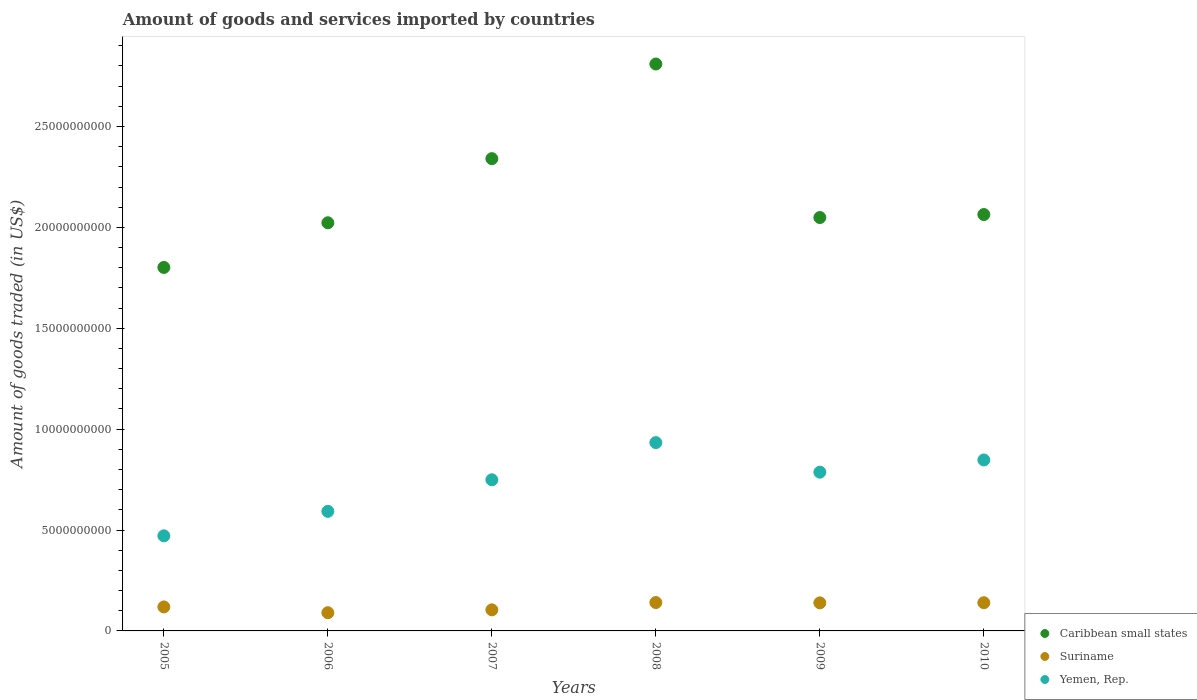How many different coloured dotlines are there?
Your answer should be compact. 3. What is the total amount of goods and services imported in Yemen, Rep. in 2005?
Your answer should be very brief. 4.71e+09. Across all years, what is the maximum total amount of goods and services imported in Yemen, Rep.?
Ensure brevity in your answer.  9.33e+09. Across all years, what is the minimum total amount of goods and services imported in Suriname?
Make the answer very short. 9.03e+08. In which year was the total amount of goods and services imported in Yemen, Rep. maximum?
Keep it short and to the point. 2008. What is the total total amount of goods and services imported in Caribbean small states in the graph?
Your answer should be compact. 1.31e+11. What is the difference between the total amount of goods and services imported in Yemen, Rep. in 2005 and that in 2007?
Provide a short and direct response. -2.78e+09. What is the difference between the total amount of goods and services imported in Yemen, Rep. in 2008 and the total amount of goods and services imported in Caribbean small states in 2007?
Provide a succinct answer. -1.41e+1. What is the average total amount of goods and services imported in Caribbean small states per year?
Provide a succinct answer. 2.18e+1. In the year 2008, what is the difference between the total amount of goods and services imported in Suriname and total amount of goods and services imported in Yemen, Rep.?
Ensure brevity in your answer.  -7.93e+09. What is the ratio of the total amount of goods and services imported in Suriname in 2007 to that in 2008?
Your response must be concise. 0.74. Is the total amount of goods and services imported in Yemen, Rep. in 2009 less than that in 2010?
Provide a succinct answer. Yes. What is the difference between the highest and the second highest total amount of goods and services imported in Suriname?
Give a very brief answer. 8.80e+06. What is the difference between the highest and the lowest total amount of goods and services imported in Yemen, Rep.?
Your answer should be very brief. 4.62e+09. Is it the case that in every year, the sum of the total amount of goods and services imported in Caribbean small states and total amount of goods and services imported in Suriname  is greater than the total amount of goods and services imported in Yemen, Rep.?
Your answer should be very brief. Yes. How many dotlines are there?
Your answer should be very brief. 3. Does the graph contain any zero values?
Provide a short and direct response. No. Does the graph contain grids?
Provide a short and direct response. No. Where does the legend appear in the graph?
Keep it short and to the point. Bottom right. How many legend labels are there?
Provide a short and direct response. 3. How are the legend labels stacked?
Keep it short and to the point. Vertical. What is the title of the graph?
Your answer should be compact. Amount of goods and services imported by countries. Does "Liechtenstein" appear as one of the legend labels in the graph?
Your response must be concise. No. What is the label or title of the X-axis?
Ensure brevity in your answer.  Years. What is the label or title of the Y-axis?
Make the answer very short. Amount of goods traded (in US$). What is the Amount of goods traded (in US$) in Caribbean small states in 2005?
Provide a short and direct response. 1.80e+1. What is the Amount of goods traded (in US$) in Suriname in 2005?
Your response must be concise. 1.19e+09. What is the Amount of goods traded (in US$) of Yemen, Rep. in 2005?
Your answer should be compact. 4.71e+09. What is the Amount of goods traded (in US$) of Caribbean small states in 2006?
Provide a short and direct response. 2.02e+1. What is the Amount of goods traded (in US$) of Suriname in 2006?
Give a very brief answer. 9.03e+08. What is the Amount of goods traded (in US$) of Yemen, Rep. in 2006?
Offer a terse response. 5.93e+09. What is the Amount of goods traded (in US$) of Caribbean small states in 2007?
Give a very brief answer. 2.34e+1. What is the Amount of goods traded (in US$) of Suriname in 2007?
Your answer should be very brief. 1.04e+09. What is the Amount of goods traded (in US$) of Yemen, Rep. in 2007?
Your response must be concise. 7.49e+09. What is the Amount of goods traded (in US$) in Caribbean small states in 2008?
Give a very brief answer. 2.81e+1. What is the Amount of goods traded (in US$) of Suriname in 2008?
Provide a short and direct response. 1.41e+09. What is the Amount of goods traded (in US$) of Yemen, Rep. in 2008?
Offer a very short reply. 9.33e+09. What is the Amount of goods traded (in US$) in Caribbean small states in 2009?
Your answer should be compact. 2.05e+1. What is the Amount of goods traded (in US$) in Suriname in 2009?
Your answer should be very brief. 1.39e+09. What is the Amount of goods traded (in US$) of Yemen, Rep. in 2009?
Offer a terse response. 7.87e+09. What is the Amount of goods traded (in US$) of Caribbean small states in 2010?
Your answer should be compact. 2.06e+1. What is the Amount of goods traded (in US$) of Suriname in 2010?
Provide a succinct answer. 1.40e+09. What is the Amount of goods traded (in US$) of Yemen, Rep. in 2010?
Offer a terse response. 8.47e+09. Across all years, what is the maximum Amount of goods traded (in US$) of Caribbean small states?
Your response must be concise. 2.81e+1. Across all years, what is the maximum Amount of goods traded (in US$) in Suriname?
Provide a short and direct response. 1.41e+09. Across all years, what is the maximum Amount of goods traded (in US$) of Yemen, Rep.?
Keep it short and to the point. 9.33e+09. Across all years, what is the minimum Amount of goods traded (in US$) in Caribbean small states?
Offer a terse response. 1.80e+1. Across all years, what is the minimum Amount of goods traded (in US$) of Suriname?
Provide a short and direct response. 9.03e+08. Across all years, what is the minimum Amount of goods traded (in US$) in Yemen, Rep.?
Make the answer very short. 4.71e+09. What is the total Amount of goods traded (in US$) of Caribbean small states in the graph?
Your answer should be compact. 1.31e+11. What is the total Amount of goods traded (in US$) of Suriname in the graph?
Offer a very short reply. 7.33e+09. What is the total Amount of goods traded (in US$) in Yemen, Rep. in the graph?
Offer a very short reply. 4.38e+1. What is the difference between the Amount of goods traded (in US$) of Caribbean small states in 2005 and that in 2006?
Ensure brevity in your answer.  -2.21e+09. What is the difference between the Amount of goods traded (in US$) of Suriname in 2005 and that in 2006?
Offer a very short reply. 2.86e+08. What is the difference between the Amount of goods traded (in US$) in Yemen, Rep. in 2005 and that in 2006?
Give a very brief answer. -1.21e+09. What is the difference between the Amount of goods traded (in US$) of Caribbean small states in 2005 and that in 2007?
Your answer should be compact. -5.39e+09. What is the difference between the Amount of goods traded (in US$) in Suriname in 2005 and that in 2007?
Provide a short and direct response. 1.44e+08. What is the difference between the Amount of goods traded (in US$) in Yemen, Rep. in 2005 and that in 2007?
Ensure brevity in your answer.  -2.78e+09. What is the difference between the Amount of goods traded (in US$) of Caribbean small states in 2005 and that in 2008?
Offer a terse response. -1.01e+1. What is the difference between the Amount of goods traded (in US$) of Suriname in 2005 and that in 2008?
Offer a very short reply. -2.18e+08. What is the difference between the Amount of goods traded (in US$) in Yemen, Rep. in 2005 and that in 2008?
Your answer should be very brief. -4.62e+09. What is the difference between the Amount of goods traded (in US$) of Caribbean small states in 2005 and that in 2009?
Provide a short and direct response. -2.47e+09. What is the difference between the Amount of goods traded (in US$) in Suriname in 2005 and that in 2009?
Keep it short and to the point. -2.02e+08. What is the difference between the Amount of goods traded (in US$) in Yemen, Rep. in 2005 and that in 2009?
Your response must be concise. -3.15e+09. What is the difference between the Amount of goods traded (in US$) in Caribbean small states in 2005 and that in 2010?
Offer a very short reply. -2.62e+09. What is the difference between the Amount of goods traded (in US$) in Suriname in 2005 and that in 2010?
Offer a very short reply. -2.09e+08. What is the difference between the Amount of goods traded (in US$) of Yemen, Rep. in 2005 and that in 2010?
Offer a terse response. -3.76e+09. What is the difference between the Amount of goods traded (in US$) of Caribbean small states in 2006 and that in 2007?
Your answer should be very brief. -3.18e+09. What is the difference between the Amount of goods traded (in US$) in Suriname in 2006 and that in 2007?
Your answer should be compact. -1.42e+08. What is the difference between the Amount of goods traded (in US$) in Yemen, Rep. in 2006 and that in 2007?
Provide a short and direct response. -1.56e+09. What is the difference between the Amount of goods traded (in US$) in Caribbean small states in 2006 and that in 2008?
Ensure brevity in your answer.  -7.87e+09. What is the difference between the Amount of goods traded (in US$) of Suriname in 2006 and that in 2008?
Give a very brief answer. -5.04e+08. What is the difference between the Amount of goods traded (in US$) of Yemen, Rep. in 2006 and that in 2008?
Your response must be concise. -3.41e+09. What is the difference between the Amount of goods traded (in US$) in Caribbean small states in 2006 and that in 2009?
Your answer should be very brief. -2.59e+08. What is the difference between the Amount of goods traded (in US$) of Suriname in 2006 and that in 2009?
Offer a terse response. -4.88e+08. What is the difference between the Amount of goods traded (in US$) of Yemen, Rep. in 2006 and that in 2009?
Provide a short and direct response. -1.94e+09. What is the difference between the Amount of goods traded (in US$) of Caribbean small states in 2006 and that in 2010?
Offer a terse response. -4.09e+08. What is the difference between the Amount of goods traded (in US$) in Suriname in 2006 and that in 2010?
Ensure brevity in your answer.  -4.95e+08. What is the difference between the Amount of goods traded (in US$) in Yemen, Rep. in 2006 and that in 2010?
Provide a succinct answer. -2.55e+09. What is the difference between the Amount of goods traded (in US$) of Caribbean small states in 2007 and that in 2008?
Your response must be concise. -4.69e+09. What is the difference between the Amount of goods traded (in US$) of Suriname in 2007 and that in 2008?
Offer a very short reply. -3.62e+08. What is the difference between the Amount of goods traded (in US$) in Yemen, Rep. in 2007 and that in 2008?
Your answer should be compact. -1.84e+09. What is the difference between the Amount of goods traded (in US$) of Caribbean small states in 2007 and that in 2009?
Provide a short and direct response. 2.92e+09. What is the difference between the Amount of goods traded (in US$) of Suriname in 2007 and that in 2009?
Make the answer very short. -3.46e+08. What is the difference between the Amount of goods traded (in US$) of Yemen, Rep. in 2007 and that in 2009?
Keep it short and to the point. -3.78e+08. What is the difference between the Amount of goods traded (in US$) in Caribbean small states in 2007 and that in 2010?
Make the answer very short. 2.77e+09. What is the difference between the Amount of goods traded (in US$) in Suriname in 2007 and that in 2010?
Offer a terse response. -3.53e+08. What is the difference between the Amount of goods traded (in US$) of Yemen, Rep. in 2007 and that in 2010?
Keep it short and to the point. -9.83e+08. What is the difference between the Amount of goods traded (in US$) of Caribbean small states in 2008 and that in 2009?
Your response must be concise. 7.61e+09. What is the difference between the Amount of goods traded (in US$) in Suriname in 2008 and that in 2009?
Give a very brief answer. 1.60e+07. What is the difference between the Amount of goods traded (in US$) in Yemen, Rep. in 2008 and that in 2009?
Your response must be concise. 1.47e+09. What is the difference between the Amount of goods traded (in US$) in Caribbean small states in 2008 and that in 2010?
Provide a short and direct response. 7.46e+09. What is the difference between the Amount of goods traded (in US$) in Suriname in 2008 and that in 2010?
Keep it short and to the point. 8.80e+06. What is the difference between the Amount of goods traded (in US$) in Yemen, Rep. in 2008 and that in 2010?
Your answer should be compact. 8.61e+08. What is the difference between the Amount of goods traded (in US$) in Caribbean small states in 2009 and that in 2010?
Provide a succinct answer. -1.49e+08. What is the difference between the Amount of goods traded (in US$) of Suriname in 2009 and that in 2010?
Ensure brevity in your answer.  -7.20e+06. What is the difference between the Amount of goods traded (in US$) in Yemen, Rep. in 2009 and that in 2010?
Your response must be concise. -6.05e+08. What is the difference between the Amount of goods traded (in US$) in Caribbean small states in 2005 and the Amount of goods traded (in US$) in Suriname in 2006?
Ensure brevity in your answer.  1.71e+1. What is the difference between the Amount of goods traded (in US$) of Caribbean small states in 2005 and the Amount of goods traded (in US$) of Yemen, Rep. in 2006?
Give a very brief answer. 1.21e+1. What is the difference between the Amount of goods traded (in US$) in Suriname in 2005 and the Amount of goods traded (in US$) in Yemen, Rep. in 2006?
Make the answer very short. -4.74e+09. What is the difference between the Amount of goods traded (in US$) of Caribbean small states in 2005 and the Amount of goods traded (in US$) of Suriname in 2007?
Keep it short and to the point. 1.70e+1. What is the difference between the Amount of goods traded (in US$) in Caribbean small states in 2005 and the Amount of goods traded (in US$) in Yemen, Rep. in 2007?
Provide a succinct answer. 1.05e+1. What is the difference between the Amount of goods traded (in US$) in Suriname in 2005 and the Amount of goods traded (in US$) in Yemen, Rep. in 2007?
Ensure brevity in your answer.  -6.30e+09. What is the difference between the Amount of goods traded (in US$) of Caribbean small states in 2005 and the Amount of goods traded (in US$) of Suriname in 2008?
Ensure brevity in your answer.  1.66e+1. What is the difference between the Amount of goods traded (in US$) in Caribbean small states in 2005 and the Amount of goods traded (in US$) in Yemen, Rep. in 2008?
Make the answer very short. 8.68e+09. What is the difference between the Amount of goods traded (in US$) in Suriname in 2005 and the Amount of goods traded (in US$) in Yemen, Rep. in 2008?
Provide a succinct answer. -8.14e+09. What is the difference between the Amount of goods traded (in US$) in Caribbean small states in 2005 and the Amount of goods traded (in US$) in Suriname in 2009?
Your answer should be compact. 1.66e+1. What is the difference between the Amount of goods traded (in US$) in Caribbean small states in 2005 and the Amount of goods traded (in US$) in Yemen, Rep. in 2009?
Offer a very short reply. 1.01e+1. What is the difference between the Amount of goods traded (in US$) in Suriname in 2005 and the Amount of goods traded (in US$) in Yemen, Rep. in 2009?
Offer a terse response. -6.68e+09. What is the difference between the Amount of goods traded (in US$) of Caribbean small states in 2005 and the Amount of goods traded (in US$) of Suriname in 2010?
Provide a succinct answer. 1.66e+1. What is the difference between the Amount of goods traded (in US$) in Caribbean small states in 2005 and the Amount of goods traded (in US$) in Yemen, Rep. in 2010?
Provide a short and direct response. 9.54e+09. What is the difference between the Amount of goods traded (in US$) of Suriname in 2005 and the Amount of goods traded (in US$) of Yemen, Rep. in 2010?
Provide a short and direct response. -7.28e+09. What is the difference between the Amount of goods traded (in US$) in Caribbean small states in 2006 and the Amount of goods traded (in US$) in Suriname in 2007?
Make the answer very short. 1.92e+1. What is the difference between the Amount of goods traded (in US$) in Caribbean small states in 2006 and the Amount of goods traded (in US$) in Yemen, Rep. in 2007?
Offer a very short reply. 1.27e+1. What is the difference between the Amount of goods traded (in US$) of Suriname in 2006 and the Amount of goods traded (in US$) of Yemen, Rep. in 2007?
Your answer should be very brief. -6.59e+09. What is the difference between the Amount of goods traded (in US$) of Caribbean small states in 2006 and the Amount of goods traded (in US$) of Suriname in 2008?
Offer a terse response. 1.88e+1. What is the difference between the Amount of goods traded (in US$) in Caribbean small states in 2006 and the Amount of goods traded (in US$) in Yemen, Rep. in 2008?
Make the answer very short. 1.09e+1. What is the difference between the Amount of goods traded (in US$) in Suriname in 2006 and the Amount of goods traded (in US$) in Yemen, Rep. in 2008?
Ensure brevity in your answer.  -8.43e+09. What is the difference between the Amount of goods traded (in US$) of Caribbean small states in 2006 and the Amount of goods traded (in US$) of Suriname in 2009?
Ensure brevity in your answer.  1.88e+1. What is the difference between the Amount of goods traded (in US$) in Caribbean small states in 2006 and the Amount of goods traded (in US$) in Yemen, Rep. in 2009?
Ensure brevity in your answer.  1.24e+1. What is the difference between the Amount of goods traded (in US$) of Suriname in 2006 and the Amount of goods traded (in US$) of Yemen, Rep. in 2009?
Your answer should be compact. -6.97e+09. What is the difference between the Amount of goods traded (in US$) of Caribbean small states in 2006 and the Amount of goods traded (in US$) of Suriname in 2010?
Offer a very short reply. 1.88e+1. What is the difference between the Amount of goods traded (in US$) in Caribbean small states in 2006 and the Amount of goods traded (in US$) in Yemen, Rep. in 2010?
Offer a terse response. 1.18e+1. What is the difference between the Amount of goods traded (in US$) in Suriname in 2006 and the Amount of goods traded (in US$) in Yemen, Rep. in 2010?
Keep it short and to the point. -7.57e+09. What is the difference between the Amount of goods traded (in US$) in Caribbean small states in 2007 and the Amount of goods traded (in US$) in Suriname in 2008?
Provide a succinct answer. 2.20e+1. What is the difference between the Amount of goods traded (in US$) of Caribbean small states in 2007 and the Amount of goods traded (in US$) of Yemen, Rep. in 2008?
Your answer should be compact. 1.41e+1. What is the difference between the Amount of goods traded (in US$) of Suriname in 2007 and the Amount of goods traded (in US$) of Yemen, Rep. in 2008?
Your answer should be compact. -8.29e+09. What is the difference between the Amount of goods traded (in US$) of Caribbean small states in 2007 and the Amount of goods traded (in US$) of Suriname in 2009?
Provide a succinct answer. 2.20e+1. What is the difference between the Amount of goods traded (in US$) of Caribbean small states in 2007 and the Amount of goods traded (in US$) of Yemen, Rep. in 2009?
Provide a short and direct response. 1.55e+1. What is the difference between the Amount of goods traded (in US$) of Suriname in 2007 and the Amount of goods traded (in US$) of Yemen, Rep. in 2009?
Provide a short and direct response. -6.82e+09. What is the difference between the Amount of goods traded (in US$) of Caribbean small states in 2007 and the Amount of goods traded (in US$) of Suriname in 2010?
Give a very brief answer. 2.20e+1. What is the difference between the Amount of goods traded (in US$) in Caribbean small states in 2007 and the Amount of goods traded (in US$) in Yemen, Rep. in 2010?
Provide a short and direct response. 1.49e+1. What is the difference between the Amount of goods traded (in US$) of Suriname in 2007 and the Amount of goods traded (in US$) of Yemen, Rep. in 2010?
Provide a succinct answer. -7.43e+09. What is the difference between the Amount of goods traded (in US$) in Caribbean small states in 2008 and the Amount of goods traded (in US$) in Suriname in 2009?
Your answer should be compact. 2.67e+1. What is the difference between the Amount of goods traded (in US$) in Caribbean small states in 2008 and the Amount of goods traded (in US$) in Yemen, Rep. in 2009?
Keep it short and to the point. 2.02e+1. What is the difference between the Amount of goods traded (in US$) in Suriname in 2008 and the Amount of goods traded (in US$) in Yemen, Rep. in 2009?
Ensure brevity in your answer.  -6.46e+09. What is the difference between the Amount of goods traded (in US$) of Caribbean small states in 2008 and the Amount of goods traded (in US$) of Suriname in 2010?
Your response must be concise. 2.67e+1. What is the difference between the Amount of goods traded (in US$) of Caribbean small states in 2008 and the Amount of goods traded (in US$) of Yemen, Rep. in 2010?
Ensure brevity in your answer.  1.96e+1. What is the difference between the Amount of goods traded (in US$) in Suriname in 2008 and the Amount of goods traded (in US$) in Yemen, Rep. in 2010?
Ensure brevity in your answer.  -7.07e+09. What is the difference between the Amount of goods traded (in US$) in Caribbean small states in 2009 and the Amount of goods traded (in US$) in Suriname in 2010?
Your response must be concise. 1.91e+1. What is the difference between the Amount of goods traded (in US$) of Caribbean small states in 2009 and the Amount of goods traded (in US$) of Yemen, Rep. in 2010?
Your answer should be very brief. 1.20e+1. What is the difference between the Amount of goods traded (in US$) of Suriname in 2009 and the Amount of goods traded (in US$) of Yemen, Rep. in 2010?
Keep it short and to the point. -7.08e+09. What is the average Amount of goods traded (in US$) of Caribbean small states per year?
Keep it short and to the point. 2.18e+1. What is the average Amount of goods traded (in US$) in Suriname per year?
Provide a short and direct response. 1.22e+09. What is the average Amount of goods traded (in US$) in Yemen, Rep. per year?
Offer a very short reply. 7.30e+09. In the year 2005, what is the difference between the Amount of goods traded (in US$) in Caribbean small states and Amount of goods traded (in US$) in Suriname?
Offer a very short reply. 1.68e+1. In the year 2005, what is the difference between the Amount of goods traded (in US$) in Caribbean small states and Amount of goods traded (in US$) in Yemen, Rep.?
Your answer should be compact. 1.33e+1. In the year 2005, what is the difference between the Amount of goods traded (in US$) in Suriname and Amount of goods traded (in US$) in Yemen, Rep.?
Keep it short and to the point. -3.52e+09. In the year 2006, what is the difference between the Amount of goods traded (in US$) of Caribbean small states and Amount of goods traded (in US$) of Suriname?
Your answer should be very brief. 1.93e+1. In the year 2006, what is the difference between the Amount of goods traded (in US$) of Caribbean small states and Amount of goods traded (in US$) of Yemen, Rep.?
Offer a terse response. 1.43e+1. In the year 2006, what is the difference between the Amount of goods traded (in US$) of Suriname and Amount of goods traded (in US$) of Yemen, Rep.?
Your answer should be compact. -5.02e+09. In the year 2007, what is the difference between the Amount of goods traded (in US$) of Caribbean small states and Amount of goods traded (in US$) of Suriname?
Keep it short and to the point. 2.24e+1. In the year 2007, what is the difference between the Amount of goods traded (in US$) in Caribbean small states and Amount of goods traded (in US$) in Yemen, Rep.?
Keep it short and to the point. 1.59e+1. In the year 2007, what is the difference between the Amount of goods traded (in US$) in Suriname and Amount of goods traded (in US$) in Yemen, Rep.?
Offer a terse response. -6.45e+09. In the year 2008, what is the difference between the Amount of goods traded (in US$) in Caribbean small states and Amount of goods traded (in US$) in Suriname?
Make the answer very short. 2.67e+1. In the year 2008, what is the difference between the Amount of goods traded (in US$) of Caribbean small states and Amount of goods traded (in US$) of Yemen, Rep.?
Offer a terse response. 1.88e+1. In the year 2008, what is the difference between the Amount of goods traded (in US$) in Suriname and Amount of goods traded (in US$) in Yemen, Rep.?
Keep it short and to the point. -7.93e+09. In the year 2009, what is the difference between the Amount of goods traded (in US$) in Caribbean small states and Amount of goods traded (in US$) in Suriname?
Provide a short and direct response. 1.91e+1. In the year 2009, what is the difference between the Amount of goods traded (in US$) in Caribbean small states and Amount of goods traded (in US$) in Yemen, Rep.?
Give a very brief answer. 1.26e+1. In the year 2009, what is the difference between the Amount of goods traded (in US$) of Suriname and Amount of goods traded (in US$) of Yemen, Rep.?
Your answer should be very brief. -6.48e+09. In the year 2010, what is the difference between the Amount of goods traded (in US$) of Caribbean small states and Amount of goods traded (in US$) of Suriname?
Your answer should be very brief. 1.92e+1. In the year 2010, what is the difference between the Amount of goods traded (in US$) of Caribbean small states and Amount of goods traded (in US$) of Yemen, Rep.?
Give a very brief answer. 1.22e+1. In the year 2010, what is the difference between the Amount of goods traded (in US$) of Suriname and Amount of goods traded (in US$) of Yemen, Rep.?
Offer a terse response. -7.08e+09. What is the ratio of the Amount of goods traded (in US$) in Caribbean small states in 2005 to that in 2006?
Give a very brief answer. 0.89. What is the ratio of the Amount of goods traded (in US$) in Suriname in 2005 to that in 2006?
Provide a short and direct response. 1.32. What is the ratio of the Amount of goods traded (in US$) in Yemen, Rep. in 2005 to that in 2006?
Make the answer very short. 0.8. What is the ratio of the Amount of goods traded (in US$) in Caribbean small states in 2005 to that in 2007?
Give a very brief answer. 0.77. What is the ratio of the Amount of goods traded (in US$) in Suriname in 2005 to that in 2007?
Provide a short and direct response. 1.14. What is the ratio of the Amount of goods traded (in US$) of Yemen, Rep. in 2005 to that in 2007?
Give a very brief answer. 0.63. What is the ratio of the Amount of goods traded (in US$) of Caribbean small states in 2005 to that in 2008?
Your answer should be very brief. 0.64. What is the ratio of the Amount of goods traded (in US$) in Suriname in 2005 to that in 2008?
Provide a succinct answer. 0.85. What is the ratio of the Amount of goods traded (in US$) of Yemen, Rep. in 2005 to that in 2008?
Your answer should be very brief. 0.5. What is the ratio of the Amount of goods traded (in US$) of Caribbean small states in 2005 to that in 2009?
Provide a succinct answer. 0.88. What is the ratio of the Amount of goods traded (in US$) in Suriname in 2005 to that in 2009?
Offer a very short reply. 0.85. What is the ratio of the Amount of goods traded (in US$) in Yemen, Rep. in 2005 to that in 2009?
Your answer should be very brief. 0.6. What is the ratio of the Amount of goods traded (in US$) of Caribbean small states in 2005 to that in 2010?
Ensure brevity in your answer.  0.87. What is the ratio of the Amount of goods traded (in US$) of Suriname in 2005 to that in 2010?
Provide a short and direct response. 0.85. What is the ratio of the Amount of goods traded (in US$) in Yemen, Rep. in 2005 to that in 2010?
Your answer should be very brief. 0.56. What is the ratio of the Amount of goods traded (in US$) in Caribbean small states in 2006 to that in 2007?
Ensure brevity in your answer.  0.86. What is the ratio of the Amount of goods traded (in US$) of Suriname in 2006 to that in 2007?
Your answer should be very brief. 0.86. What is the ratio of the Amount of goods traded (in US$) in Yemen, Rep. in 2006 to that in 2007?
Offer a very short reply. 0.79. What is the ratio of the Amount of goods traded (in US$) of Caribbean small states in 2006 to that in 2008?
Give a very brief answer. 0.72. What is the ratio of the Amount of goods traded (in US$) in Suriname in 2006 to that in 2008?
Your answer should be compact. 0.64. What is the ratio of the Amount of goods traded (in US$) in Yemen, Rep. in 2006 to that in 2008?
Ensure brevity in your answer.  0.63. What is the ratio of the Amount of goods traded (in US$) of Caribbean small states in 2006 to that in 2009?
Make the answer very short. 0.99. What is the ratio of the Amount of goods traded (in US$) in Suriname in 2006 to that in 2009?
Ensure brevity in your answer.  0.65. What is the ratio of the Amount of goods traded (in US$) in Yemen, Rep. in 2006 to that in 2009?
Your answer should be compact. 0.75. What is the ratio of the Amount of goods traded (in US$) in Caribbean small states in 2006 to that in 2010?
Your answer should be compact. 0.98. What is the ratio of the Amount of goods traded (in US$) in Suriname in 2006 to that in 2010?
Provide a succinct answer. 0.65. What is the ratio of the Amount of goods traded (in US$) of Yemen, Rep. in 2006 to that in 2010?
Your answer should be very brief. 0.7. What is the ratio of the Amount of goods traded (in US$) in Caribbean small states in 2007 to that in 2008?
Offer a very short reply. 0.83. What is the ratio of the Amount of goods traded (in US$) of Suriname in 2007 to that in 2008?
Keep it short and to the point. 0.74. What is the ratio of the Amount of goods traded (in US$) in Yemen, Rep. in 2007 to that in 2008?
Your answer should be compact. 0.8. What is the ratio of the Amount of goods traded (in US$) of Caribbean small states in 2007 to that in 2009?
Your response must be concise. 1.14. What is the ratio of the Amount of goods traded (in US$) of Suriname in 2007 to that in 2009?
Ensure brevity in your answer.  0.75. What is the ratio of the Amount of goods traded (in US$) in Caribbean small states in 2007 to that in 2010?
Your answer should be very brief. 1.13. What is the ratio of the Amount of goods traded (in US$) of Suriname in 2007 to that in 2010?
Offer a terse response. 0.75. What is the ratio of the Amount of goods traded (in US$) in Yemen, Rep. in 2007 to that in 2010?
Ensure brevity in your answer.  0.88. What is the ratio of the Amount of goods traded (in US$) of Caribbean small states in 2008 to that in 2009?
Offer a terse response. 1.37. What is the ratio of the Amount of goods traded (in US$) in Suriname in 2008 to that in 2009?
Give a very brief answer. 1.01. What is the ratio of the Amount of goods traded (in US$) in Yemen, Rep. in 2008 to that in 2009?
Make the answer very short. 1.19. What is the ratio of the Amount of goods traded (in US$) in Caribbean small states in 2008 to that in 2010?
Make the answer very short. 1.36. What is the ratio of the Amount of goods traded (in US$) in Yemen, Rep. in 2008 to that in 2010?
Provide a short and direct response. 1.1. What is the ratio of the Amount of goods traded (in US$) of Caribbean small states in 2009 to that in 2010?
Offer a very short reply. 0.99. What is the ratio of the Amount of goods traded (in US$) of Yemen, Rep. in 2009 to that in 2010?
Offer a very short reply. 0.93. What is the difference between the highest and the second highest Amount of goods traded (in US$) of Caribbean small states?
Offer a very short reply. 4.69e+09. What is the difference between the highest and the second highest Amount of goods traded (in US$) in Suriname?
Ensure brevity in your answer.  8.80e+06. What is the difference between the highest and the second highest Amount of goods traded (in US$) of Yemen, Rep.?
Give a very brief answer. 8.61e+08. What is the difference between the highest and the lowest Amount of goods traded (in US$) of Caribbean small states?
Your response must be concise. 1.01e+1. What is the difference between the highest and the lowest Amount of goods traded (in US$) of Suriname?
Keep it short and to the point. 5.04e+08. What is the difference between the highest and the lowest Amount of goods traded (in US$) in Yemen, Rep.?
Your answer should be very brief. 4.62e+09. 